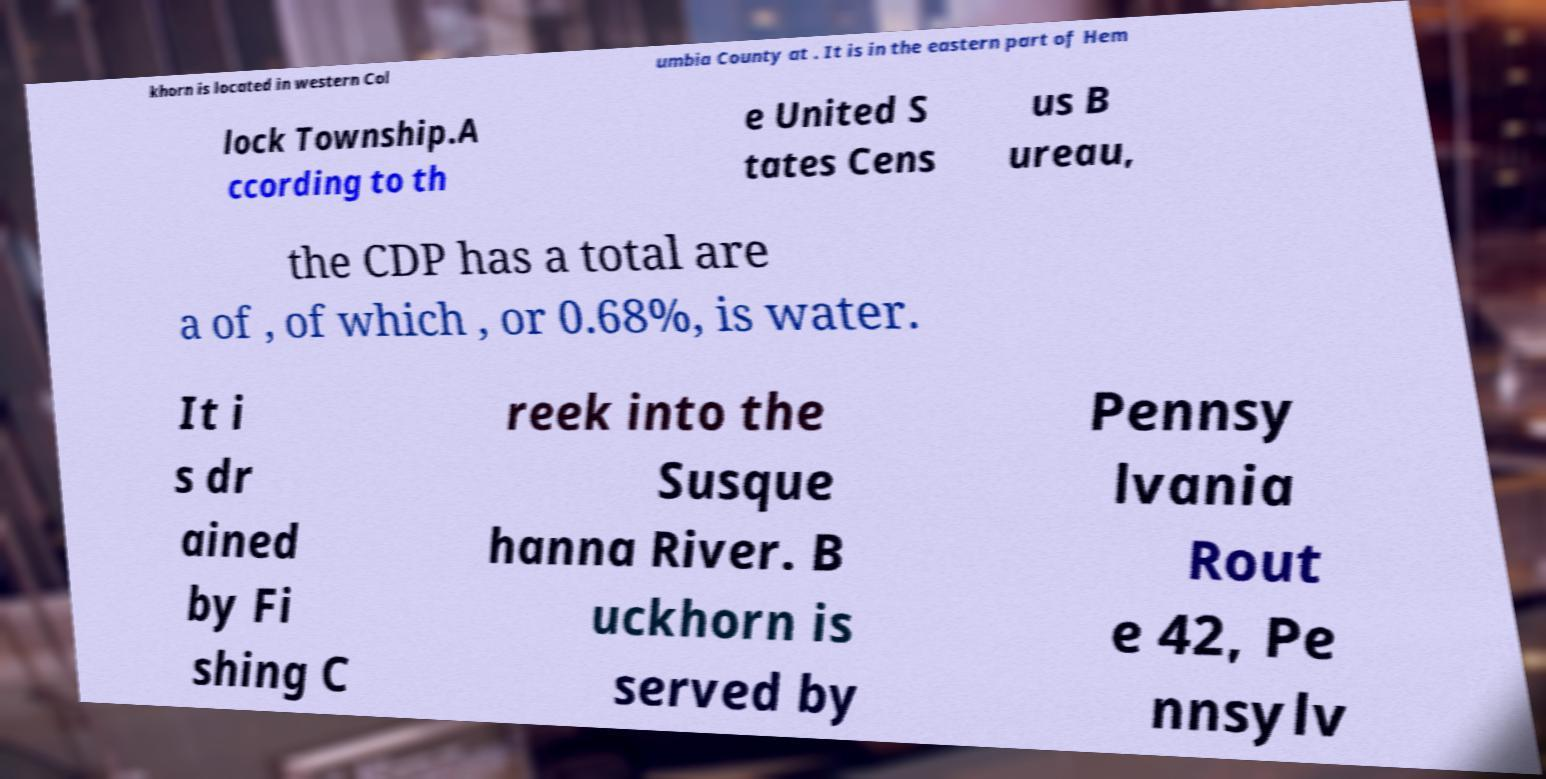Can you read and provide the text displayed in the image?This photo seems to have some interesting text. Can you extract and type it out for me? khorn is located in western Col umbia County at . It is in the eastern part of Hem lock Township.A ccording to th e United S tates Cens us B ureau, the CDP has a total are a of , of which , or 0.68%, is water. It i s dr ained by Fi shing C reek into the Susque hanna River. B uckhorn is served by Pennsy lvania Rout e 42, Pe nnsylv 